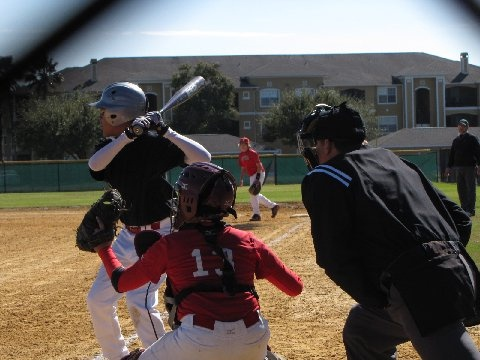Describe the objects in this image and their specific colors. I can see people in lightblue, black, and gray tones, people in lightblue, black, gray, and maroon tones, people in lightblue, black, maroon, and gray tones, baseball glove in lightblue, black, gray, and tan tones, and people in lightblue, black, gray, and darkgreen tones in this image. 